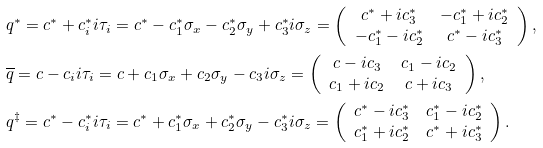<formula> <loc_0><loc_0><loc_500><loc_500>& { q } ^ { * } = c ^ { * } + c _ { i } ^ { * } i \tau _ { i } = c ^ { * } - c _ { 1 } ^ { * } \sigma _ { x } - c _ { 2 } ^ { * } \sigma _ { y } + c _ { 3 } ^ { * } i \sigma _ { z } = \left ( \begin{array} { c c } c ^ { * } + i c _ { 3 } ^ { * } & - c _ { 1 } ^ { * } + i c _ { 2 } ^ { * } \\ - c _ { 1 } ^ { * } - i c _ { 2 } ^ { * } & c ^ { * } - i c _ { 3 } ^ { * } \end{array} \right ) , \\ & \overline { q } = c - c _ { i } i \tau _ { i } = c + c _ { 1 } \sigma _ { x } + c _ { 2 } \sigma _ { y } - c _ { 3 } i \sigma _ { z } = \left ( \begin{array} { c c } c - i c _ { 3 } & c _ { 1 } - i c _ { 2 } \\ c _ { 1 } + i c _ { 2 } & c + i c _ { 3 } \end{array} \right ) , \\ & { q } ^ { \ddagger } = c ^ { * } - c _ { i } ^ { * } i \tau _ { i } = c ^ { * } + c _ { 1 } ^ { * } \sigma _ { x } + c _ { 2 } ^ { * } \sigma _ { y } - c _ { 3 } ^ { * } i \sigma _ { z } = \left ( \begin{array} { c c } c ^ { * } - i c _ { 3 } ^ { * } & c _ { 1 } ^ { * } - i c _ { 2 } ^ { * } \\ c _ { 1 } ^ { * } + i c _ { 2 } ^ { * } & c ^ { * } + i c _ { 3 } ^ { * } \end{array} \right ) .</formula> 